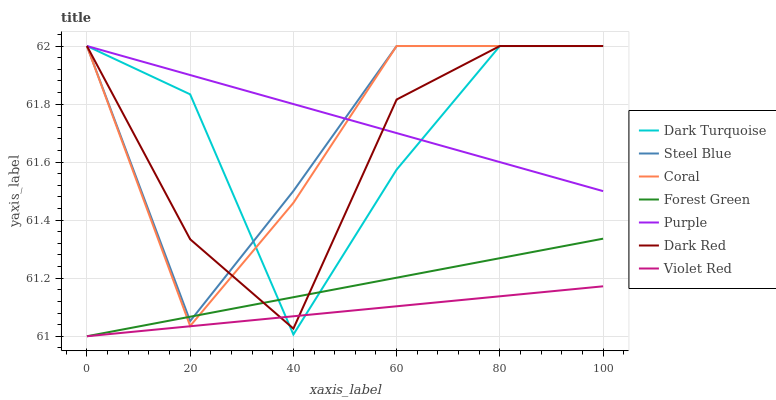Does Violet Red have the minimum area under the curve?
Answer yes or no. Yes. Does Purple have the maximum area under the curve?
Answer yes or no. Yes. Does Dark Turquoise have the minimum area under the curve?
Answer yes or no. No. Does Dark Turquoise have the maximum area under the curve?
Answer yes or no. No. Is Forest Green the smoothest?
Answer yes or no. Yes. Is Dark Turquoise the roughest?
Answer yes or no. Yes. Is Purple the smoothest?
Answer yes or no. No. Is Purple the roughest?
Answer yes or no. No. Does Violet Red have the lowest value?
Answer yes or no. Yes. Does Dark Turquoise have the lowest value?
Answer yes or no. No. Does Dark Red have the highest value?
Answer yes or no. Yes. Does Forest Green have the highest value?
Answer yes or no. No. Is Violet Red less than Coral?
Answer yes or no. Yes. Is Steel Blue greater than Violet Red?
Answer yes or no. Yes. Does Steel Blue intersect Coral?
Answer yes or no. Yes. Is Steel Blue less than Coral?
Answer yes or no. No. Is Steel Blue greater than Coral?
Answer yes or no. No. Does Violet Red intersect Coral?
Answer yes or no. No. 